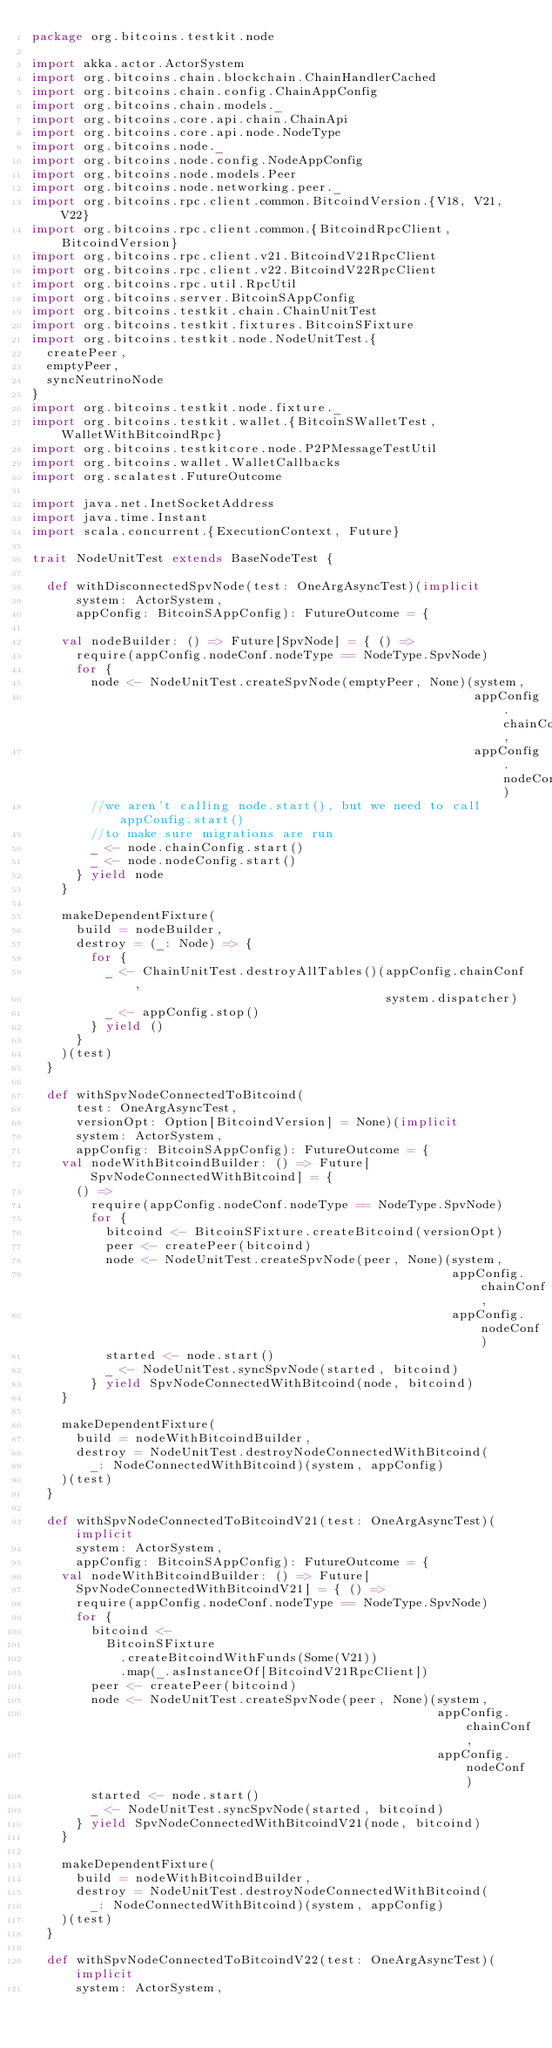<code> <loc_0><loc_0><loc_500><loc_500><_Scala_>package org.bitcoins.testkit.node

import akka.actor.ActorSystem
import org.bitcoins.chain.blockchain.ChainHandlerCached
import org.bitcoins.chain.config.ChainAppConfig
import org.bitcoins.chain.models._
import org.bitcoins.core.api.chain.ChainApi
import org.bitcoins.core.api.node.NodeType
import org.bitcoins.node._
import org.bitcoins.node.config.NodeAppConfig
import org.bitcoins.node.models.Peer
import org.bitcoins.node.networking.peer._
import org.bitcoins.rpc.client.common.BitcoindVersion.{V18, V21, V22}
import org.bitcoins.rpc.client.common.{BitcoindRpcClient, BitcoindVersion}
import org.bitcoins.rpc.client.v21.BitcoindV21RpcClient
import org.bitcoins.rpc.client.v22.BitcoindV22RpcClient
import org.bitcoins.rpc.util.RpcUtil
import org.bitcoins.server.BitcoinSAppConfig
import org.bitcoins.testkit.chain.ChainUnitTest
import org.bitcoins.testkit.fixtures.BitcoinSFixture
import org.bitcoins.testkit.node.NodeUnitTest.{
  createPeer,
  emptyPeer,
  syncNeutrinoNode
}
import org.bitcoins.testkit.node.fixture._
import org.bitcoins.testkit.wallet.{BitcoinSWalletTest, WalletWithBitcoindRpc}
import org.bitcoins.testkitcore.node.P2PMessageTestUtil
import org.bitcoins.wallet.WalletCallbacks
import org.scalatest.FutureOutcome

import java.net.InetSocketAddress
import java.time.Instant
import scala.concurrent.{ExecutionContext, Future}

trait NodeUnitTest extends BaseNodeTest {

  def withDisconnectedSpvNode(test: OneArgAsyncTest)(implicit
      system: ActorSystem,
      appConfig: BitcoinSAppConfig): FutureOutcome = {

    val nodeBuilder: () => Future[SpvNode] = { () =>
      require(appConfig.nodeConf.nodeType == NodeType.SpvNode)
      for {
        node <- NodeUnitTest.createSpvNode(emptyPeer, None)(system,
                                                            appConfig.chainConf,
                                                            appConfig.nodeConf)
        //we aren't calling node.start(), but we need to call appConfig.start()
        //to make sure migrations are run
        _ <- node.chainConfig.start()
        _ <- node.nodeConfig.start()
      } yield node
    }

    makeDependentFixture(
      build = nodeBuilder,
      destroy = (_: Node) => {
        for {
          _ <- ChainUnitTest.destroyAllTables()(appConfig.chainConf,
                                                system.dispatcher)
          _ <- appConfig.stop()
        } yield ()
      }
    )(test)
  }

  def withSpvNodeConnectedToBitcoind(
      test: OneArgAsyncTest,
      versionOpt: Option[BitcoindVersion] = None)(implicit
      system: ActorSystem,
      appConfig: BitcoinSAppConfig): FutureOutcome = {
    val nodeWithBitcoindBuilder: () => Future[SpvNodeConnectedWithBitcoind] = {
      () =>
        require(appConfig.nodeConf.nodeType == NodeType.SpvNode)
        for {
          bitcoind <- BitcoinSFixture.createBitcoind(versionOpt)
          peer <- createPeer(bitcoind)
          node <- NodeUnitTest.createSpvNode(peer, None)(system,
                                                         appConfig.chainConf,
                                                         appConfig.nodeConf)
          started <- node.start()
          _ <- NodeUnitTest.syncSpvNode(started, bitcoind)
        } yield SpvNodeConnectedWithBitcoind(node, bitcoind)
    }

    makeDependentFixture(
      build = nodeWithBitcoindBuilder,
      destroy = NodeUnitTest.destroyNodeConnectedWithBitcoind(
        _: NodeConnectedWithBitcoind)(system, appConfig)
    )(test)
  }

  def withSpvNodeConnectedToBitcoindV21(test: OneArgAsyncTest)(implicit
      system: ActorSystem,
      appConfig: BitcoinSAppConfig): FutureOutcome = {
    val nodeWithBitcoindBuilder: () => Future[
      SpvNodeConnectedWithBitcoindV21] = { () =>
      require(appConfig.nodeConf.nodeType == NodeType.SpvNode)
      for {
        bitcoind <-
          BitcoinSFixture
            .createBitcoindWithFunds(Some(V21))
            .map(_.asInstanceOf[BitcoindV21RpcClient])
        peer <- createPeer(bitcoind)
        node <- NodeUnitTest.createSpvNode(peer, None)(system,
                                                       appConfig.chainConf,
                                                       appConfig.nodeConf)
        started <- node.start()
        _ <- NodeUnitTest.syncSpvNode(started, bitcoind)
      } yield SpvNodeConnectedWithBitcoindV21(node, bitcoind)
    }

    makeDependentFixture(
      build = nodeWithBitcoindBuilder,
      destroy = NodeUnitTest.destroyNodeConnectedWithBitcoind(
        _: NodeConnectedWithBitcoind)(system, appConfig)
    )(test)
  }

  def withSpvNodeConnectedToBitcoindV22(test: OneArgAsyncTest)(implicit
      system: ActorSystem,</code> 